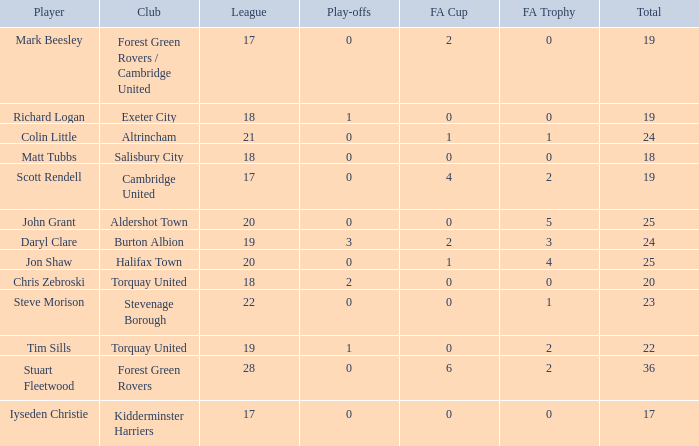Which mean total had Tim Sills as a player? 22.0. 